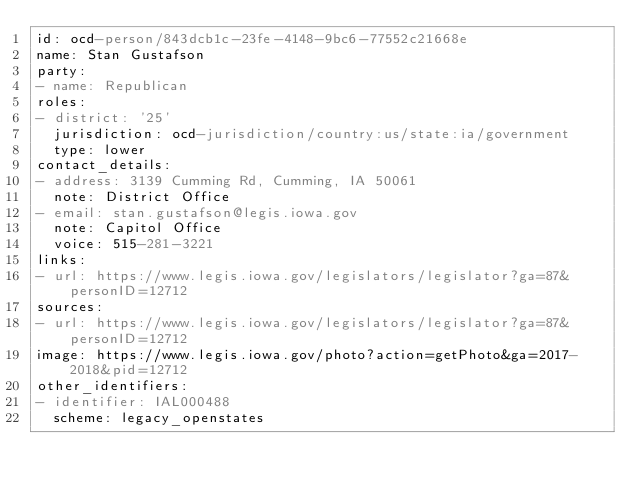Convert code to text. <code><loc_0><loc_0><loc_500><loc_500><_YAML_>id: ocd-person/843dcb1c-23fe-4148-9bc6-77552c21668e
name: Stan Gustafson
party:
- name: Republican
roles:
- district: '25'
  jurisdiction: ocd-jurisdiction/country:us/state:ia/government
  type: lower
contact_details:
- address: 3139 Cumming Rd, Cumming, IA 50061
  note: District Office
- email: stan.gustafson@legis.iowa.gov
  note: Capitol Office
  voice: 515-281-3221
links:
- url: https://www.legis.iowa.gov/legislators/legislator?ga=87&personID=12712
sources:
- url: https://www.legis.iowa.gov/legislators/legislator?ga=87&personID=12712
image: https://www.legis.iowa.gov/photo?action=getPhoto&ga=2017-2018&pid=12712
other_identifiers:
- identifier: IAL000488
  scheme: legacy_openstates
</code> 